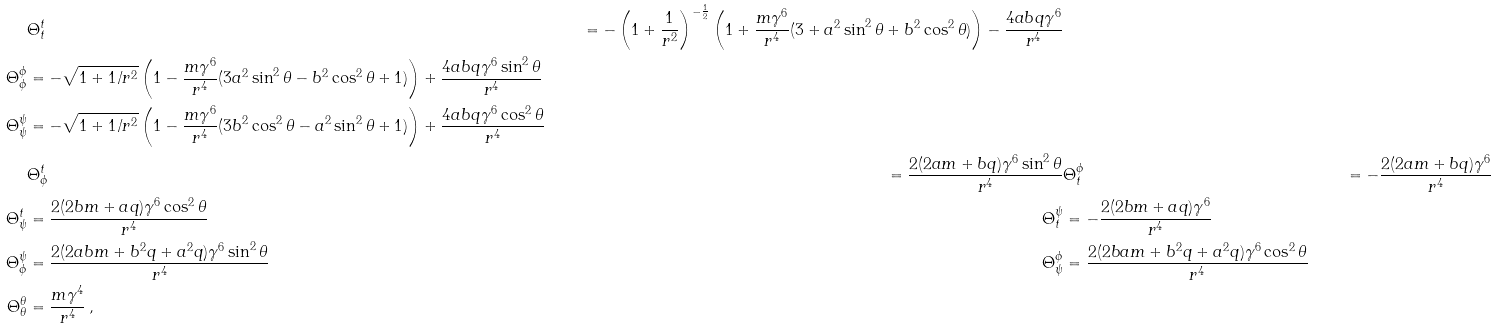<formula> <loc_0><loc_0><loc_500><loc_500>& \Theta ^ { t } _ { t } & = - \left ( 1 + \frac { 1 } { r ^ { 2 } } \right ) ^ { - \frac { 1 } { 2 } } \left ( 1 + \frac { m \gamma ^ { 6 } } { r ^ { 4 } } ( 3 + a ^ { 2 } \sin ^ { 2 } \theta + b ^ { 2 } \cos ^ { 2 } \theta ) \right ) - \frac { 4 a b q \gamma ^ { 6 } } { r ^ { 4 } } \\ \Theta ^ { \phi } _ { \phi } & = - \sqrt { 1 + 1 / r ^ { 2 } } \left ( 1 - \frac { m \gamma ^ { 6 } } { r ^ { 4 } } ( 3 a ^ { 2 } \sin ^ { 2 } \theta - b ^ { 2 } \cos ^ { 2 } \theta + 1 ) \right ) + \frac { 4 a b q \gamma ^ { 6 } \sin ^ { 2 } \theta } { r ^ { 4 } } \\ \Theta ^ { \psi } _ { \psi } & = - \sqrt { 1 + 1 / r ^ { 2 } } \left ( 1 - \frac { m \gamma ^ { 6 } } { r ^ { 4 } } ( 3 b ^ { 2 } \cos ^ { 2 } \theta - a ^ { 2 } \sin ^ { 2 } \theta + 1 ) \right ) + \frac { 4 a b q \gamma ^ { 6 } \cos ^ { 2 } \theta } { r ^ { 4 } } \\ & \Theta ^ { t } _ { \phi } & = \frac { 2 ( 2 a m + b q ) \gamma ^ { 6 } \sin ^ { 2 } \theta } { r ^ { 4 } } & \Theta ^ { \phi } _ { t } & = - \frac { 2 ( 2 a m + b q ) \gamma ^ { 6 } } { r ^ { 4 } } \\ \Theta ^ { t } _ { \psi } & = \frac { 2 ( 2 b m + a q ) \gamma ^ { 6 } \cos ^ { 2 } \theta } { r ^ { 4 } } & \Theta ^ { \psi } _ { t } & = - \frac { 2 ( 2 b m + a q ) \gamma ^ { 6 } } { r ^ { 4 } } \\ \Theta ^ { \psi } _ { \phi } & = \frac { 2 ( 2 a b m + b ^ { 2 } q + a ^ { 2 } q ) \gamma ^ { 6 } \sin ^ { 2 } \theta } { r ^ { 4 } } & \Theta ^ { \phi } _ { \psi } & = \frac { 2 ( 2 b a m + b ^ { 2 } q + a ^ { 2 } q ) \gamma ^ { 6 } \cos ^ { 2 } \theta } { r ^ { 4 } } \\ \Theta ^ { \theta } _ { \theta } & = \frac { m \gamma ^ { 4 } } { r ^ { 4 } } \, ,</formula> 